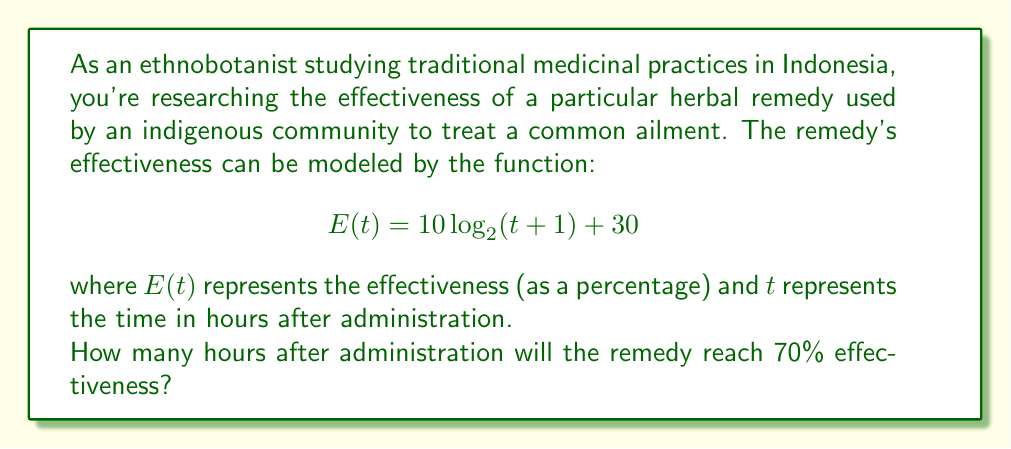Provide a solution to this math problem. To solve this problem, we need to follow these steps:

1) We want to find $t$ when $E(t) = 70$. So, let's set up the equation:

   $$70 = 10 \log_2(t+1) + 30$$

2) Subtract 30 from both sides:

   $$40 = 10 \log_2(t+1)$$

3) Divide both sides by 10:

   $$4 = \log_2(t+1)$$

4) To solve for $t$, we need to apply the inverse function of $\log_2$, which is $2^x$:

   $$2^4 = t+1$$

5) Simplify the left side:

   $$16 = t+1$$

6) Subtract 1 from both sides to isolate $t$:

   $$15 = t$$

Therefore, the remedy will reach 70% effectiveness 15 hours after administration.
Answer: 15 hours 